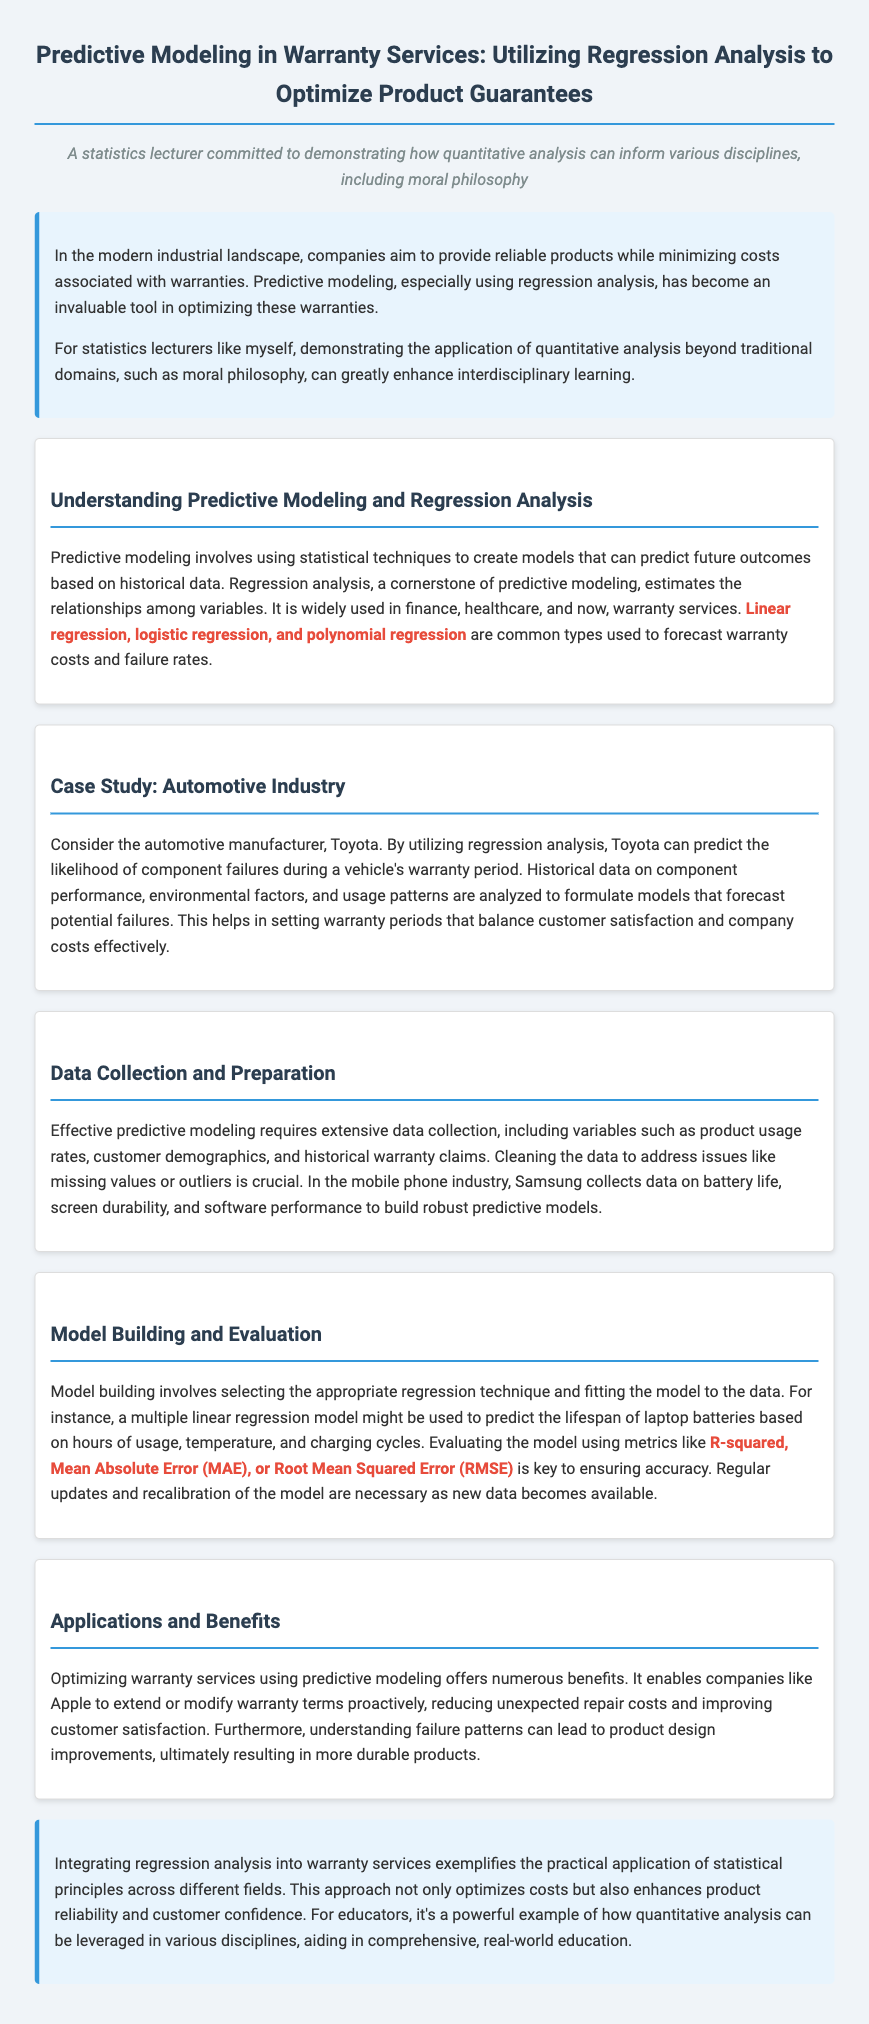What is the main purpose of predictive modeling in warranty services? The main purpose is to optimize product guarantees while minimizing costs associated with warranties.
Answer: Optimize product guarantees Which type of regression is mentioned as commonly used for predicting warranty costs? The document mentions linear regression as a common type used for predicting warranty costs.
Answer: Linear regression What automotive company is used as a case study in the document? The case study discusses the automotive manufacturer Toyota.
Answer: Toyota What metric is emphasized for evaluating the accuracy of predictive models? The document emphasizes R-squared as a key metric for evaluating model accuracy.
Answer: R-squared What kind of data does Samsung collect for predictive modeling? Samsung collects data on battery life, screen durability, and software performance for predictive modeling.
Answer: Battery life, screen durability, and software performance How do companies benefit from understanding failure patterns? Understanding failure patterns can lead to product design improvements.
Answer: Product design improvements What is one key challenge in data preparation for predictive modeling? One key challenge is addressing issues like missing values or outliers in the data.
Answer: Missing values or outliers What industry besides automotive is mentioned in relation to predictive modeling? The mobile phone industry is mentioned in relation to predictive modeling.
Answer: Mobile phone industry What is the title of the document? The title describes the use of predictive modeling in warranty services.
Answer: Predictive Modeling in Warranty Services: Utilizing Regression Analysis to Optimize Product Guarantees 